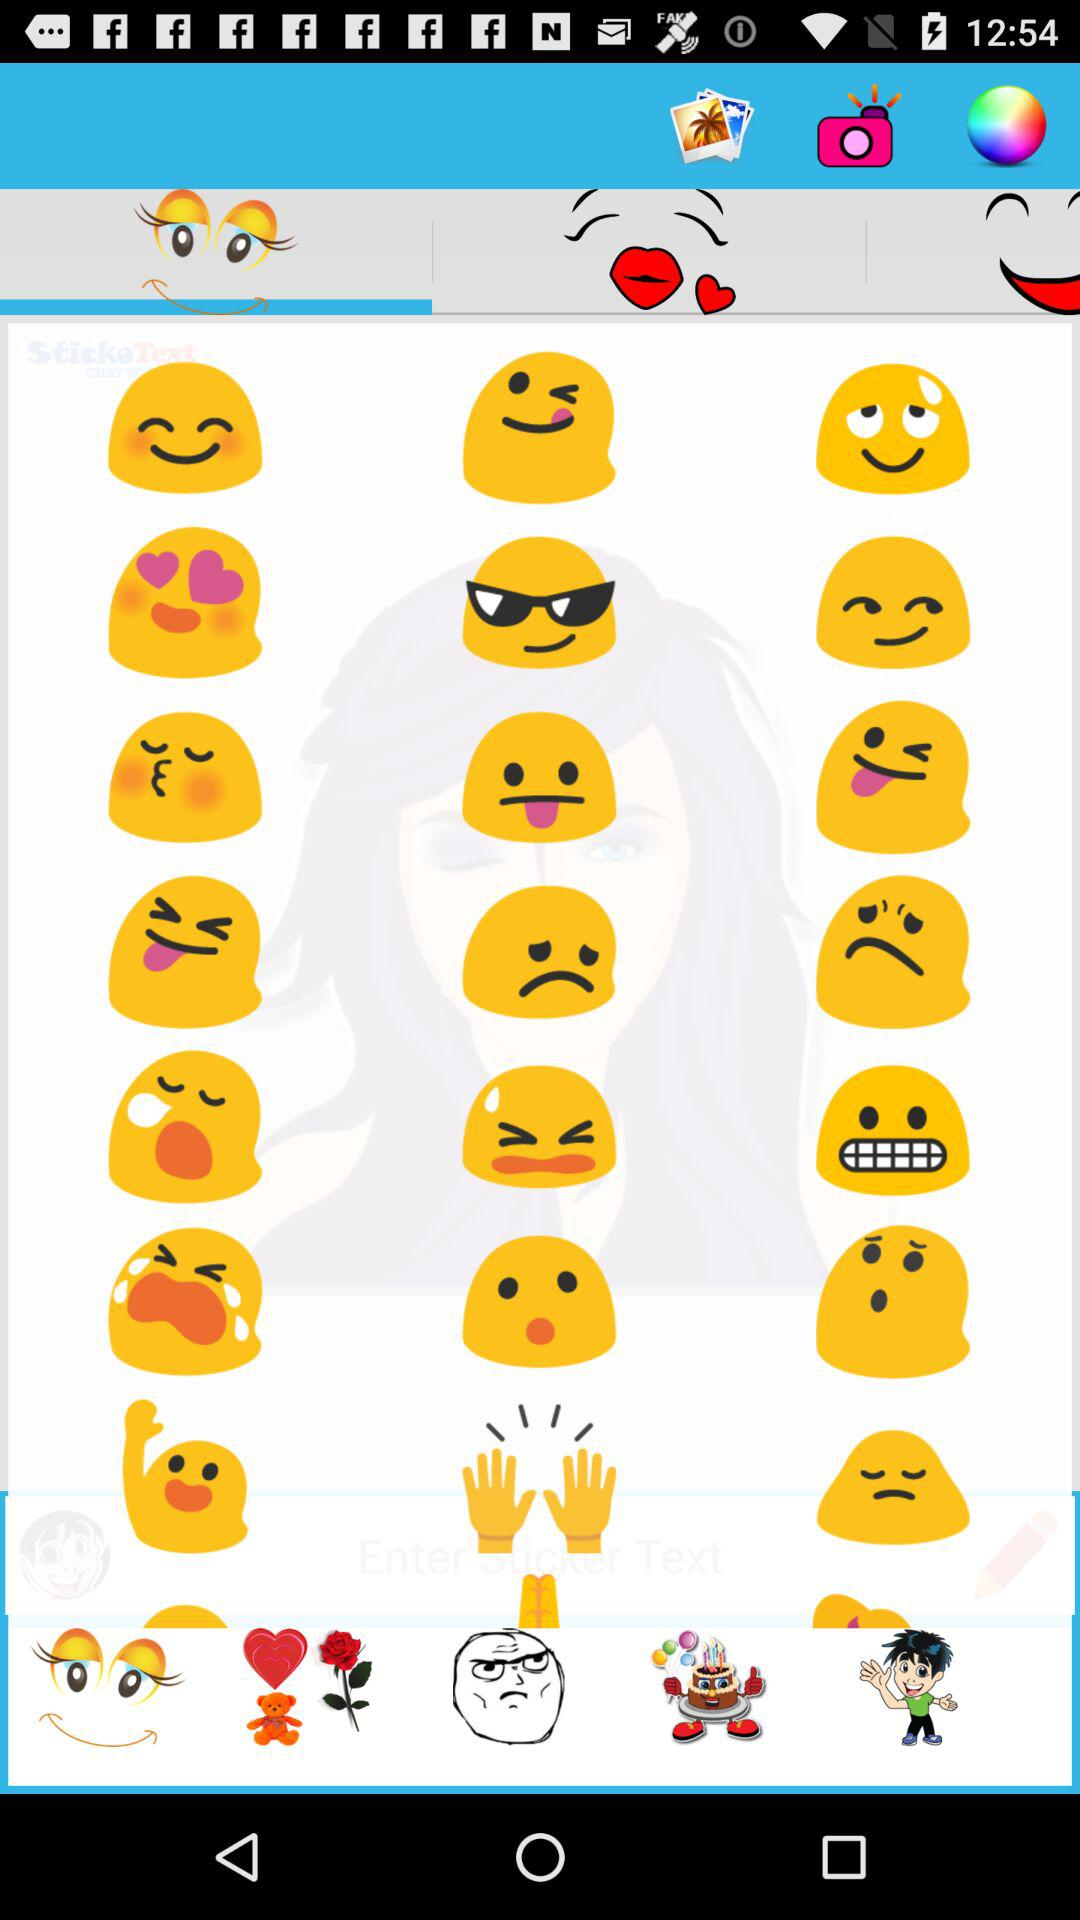How many happy faces are there in the first row?
Answer the question using a single word or phrase. 3 